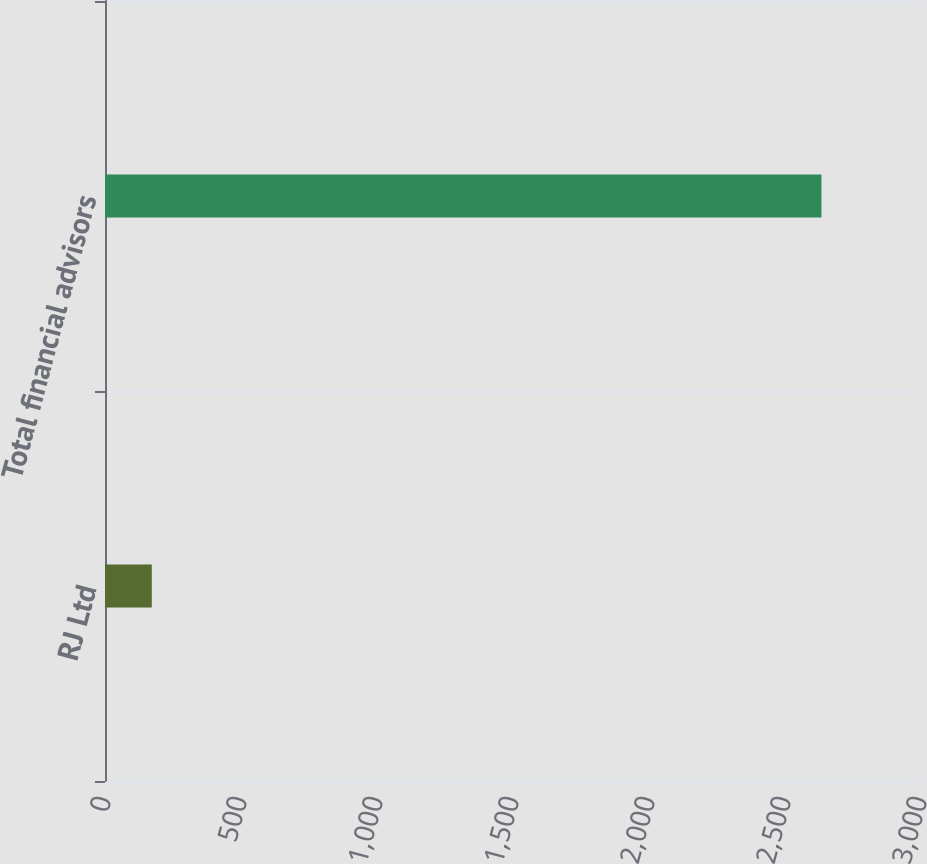Convert chart to OTSL. <chart><loc_0><loc_0><loc_500><loc_500><bar_chart><fcel>RJ Ltd<fcel>Total financial advisors<nl><fcel>172<fcel>2634<nl></chart> 